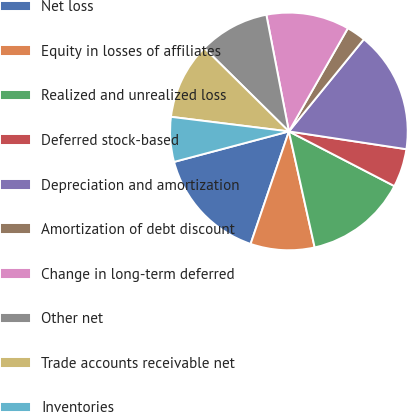Convert chart. <chart><loc_0><loc_0><loc_500><loc_500><pie_chart><fcel>Net loss<fcel>Equity in losses of affiliates<fcel>Realized and unrealized loss<fcel>Deferred stock-based<fcel>Depreciation and amortization<fcel>Amortization of debt discount<fcel>Change in long-term deferred<fcel>Other net<fcel>Trade accounts receivable net<fcel>Inventories<nl><fcel>15.65%<fcel>8.7%<fcel>13.91%<fcel>5.22%<fcel>16.52%<fcel>2.61%<fcel>11.3%<fcel>9.57%<fcel>10.43%<fcel>6.09%<nl></chart> 